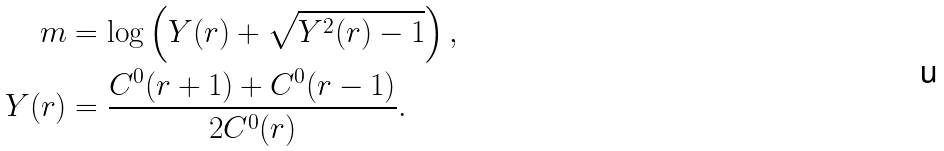Convert formula to latex. <formula><loc_0><loc_0><loc_500><loc_500>m & = \log \left ( Y ( r ) + \sqrt { Y ^ { 2 } ( r ) - 1 } \right ) , \\ Y ( r ) & = \frac { C ^ { 0 } ( r + 1 ) + C ^ { 0 } ( r - 1 ) } { 2 C ^ { 0 } ( r ) } .</formula> 